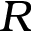Convert formula to latex. <formula><loc_0><loc_0><loc_500><loc_500>R</formula> 